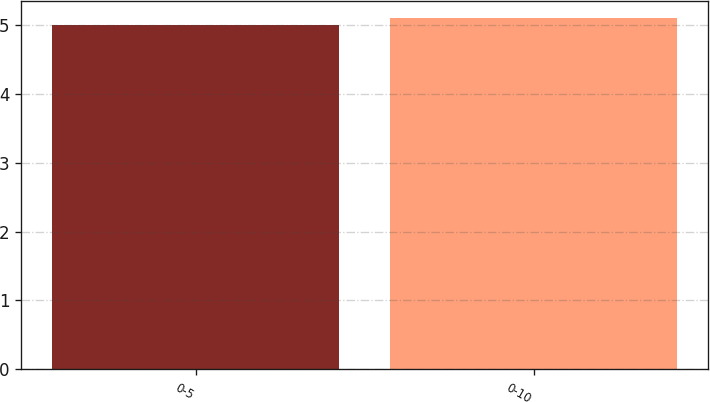Convert chart. <chart><loc_0><loc_0><loc_500><loc_500><bar_chart><fcel>0-5<fcel>0-10<nl><fcel>5<fcel>5.1<nl></chart> 